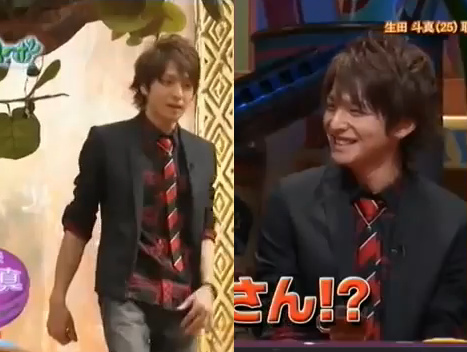What event might be happening here? It looks like the event might be a television game show or talk show, where one person is participating or being interviewed while another host engages with them. 